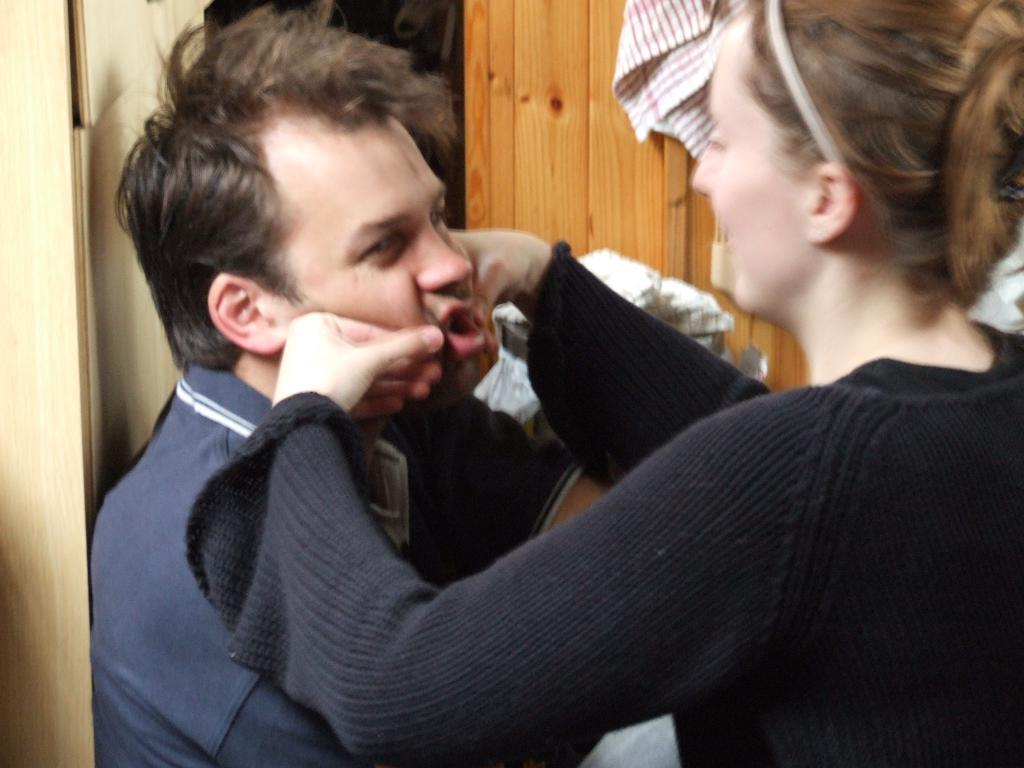How many people are present in the image? There is a man and a woman in the image. What can be seen in the background of the image? There are clothes and a wooden object in the background of the image. Where is the playground located in the image? There is no playground present in the image. What type of parcel is being delivered to the man in the image? There is no parcel or delivery being depicted in the image. 